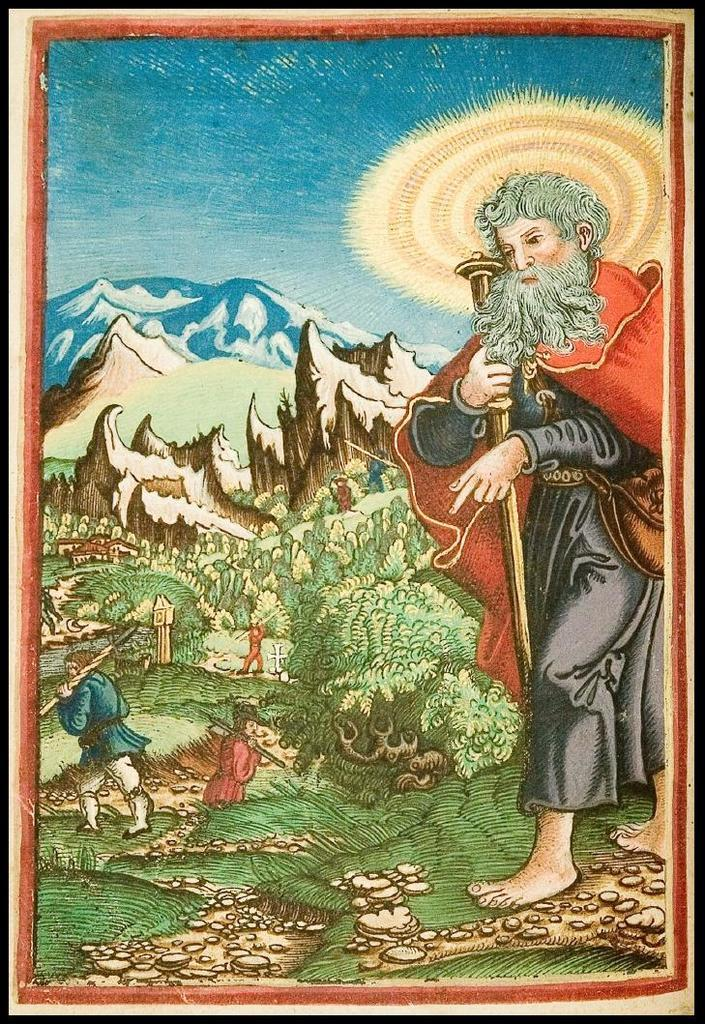What is featured on the poster in the picture? There is a poster in the picture that contains images of people, trees, mountains, and a clear sky. Can you describe the images of people on the poster? The poster contains images of people, but the specific details about the people cannot be determined from the image. What type of natural scenery is depicted on the poster? The poster contains images of trees and mountains, which are examples of natural scenery. What is the condition of the sky in the images on the poster? The poster depicts a clear sky. Where is the volleyball court located in the image? There is no volleyball court present in the image; it only features a poster with various images. Can you describe the cemetery scene on the poster? There is no cemetery scene depicted on the poster; it contains images of people, trees, mountains, and a clear sky. 